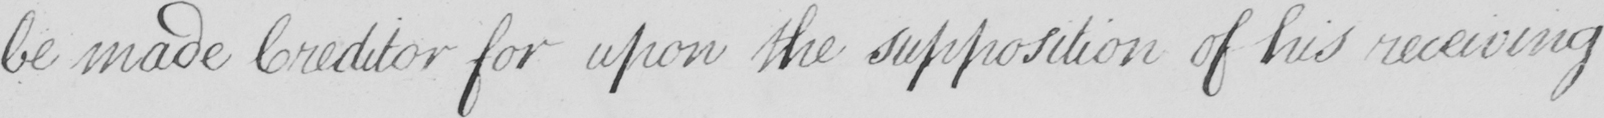What text is written in this handwritten line? be made Creditor for upon the supposition of his receiving 